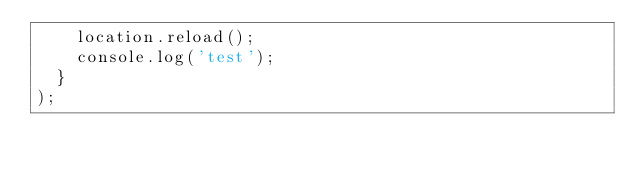Convert code to text. <code><loc_0><loc_0><loc_500><loc_500><_JavaScript_>    location.reload();
    console.log('test');
  }
);
</code> 